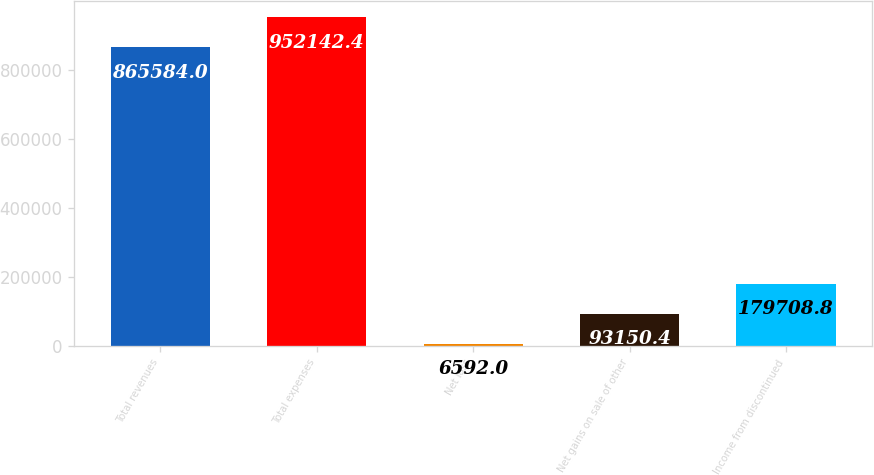Convert chart to OTSL. <chart><loc_0><loc_0><loc_500><loc_500><bar_chart><fcel>Total revenues<fcel>Total expenses<fcel>Net loss<fcel>Net gains on sale of other<fcel>Income from discontinued<nl><fcel>865584<fcel>952142<fcel>6592<fcel>93150.4<fcel>179709<nl></chart> 